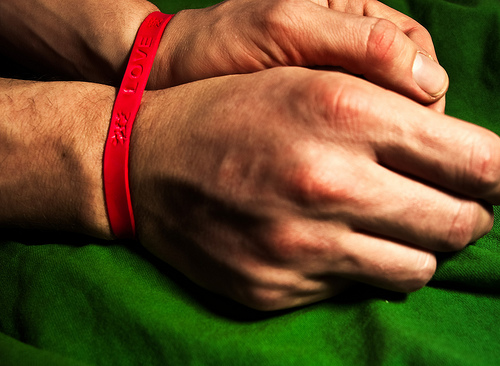<image>
Is there a hands above the band? Yes. The hands is positioned above the band in the vertical space, higher up in the scene. 